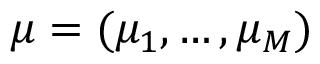Convert formula to latex. <formula><loc_0><loc_0><loc_500><loc_500>\mu = ( \mu _ { 1 } , \dots , \mu _ { M } )</formula> 